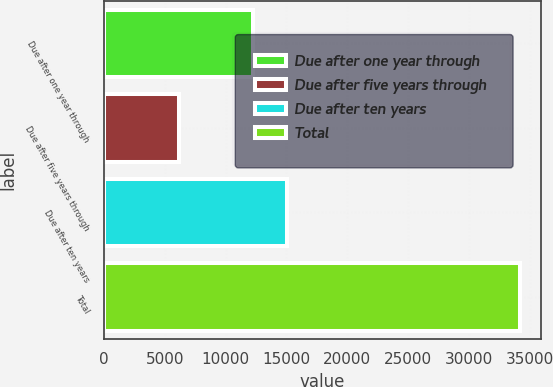Convert chart to OTSL. <chart><loc_0><loc_0><loc_500><loc_500><bar_chart><fcel>Due after one year through<fcel>Due after five years through<fcel>Due after ten years<fcel>Total<nl><fcel>12219<fcel>6150<fcel>15025.2<fcel>34212<nl></chart> 